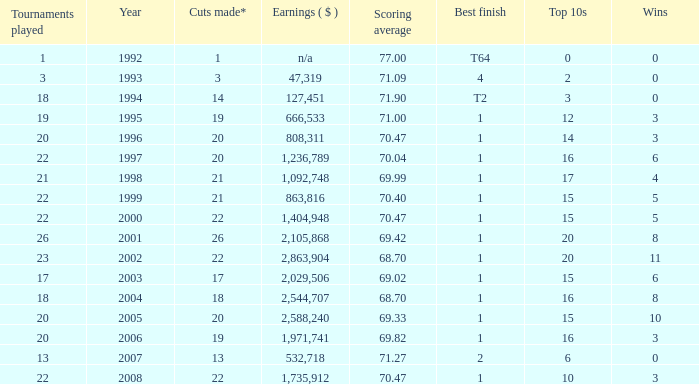Tell me the scoring average for year less than 1998 and wins more than 3 70.04. 